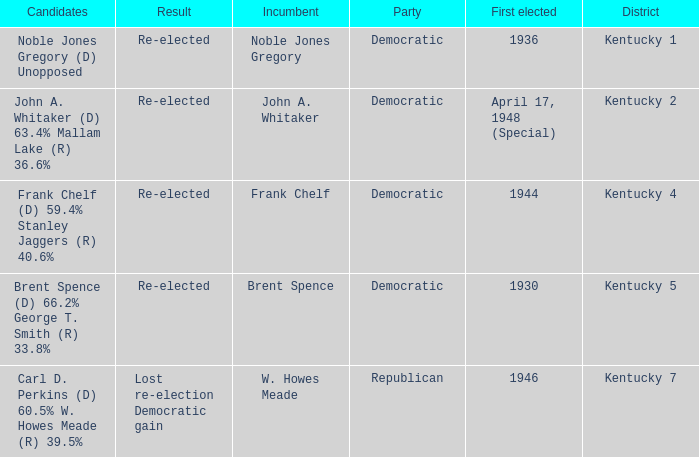Which party won in the election in voting district Kentucky 5? Democratic. 